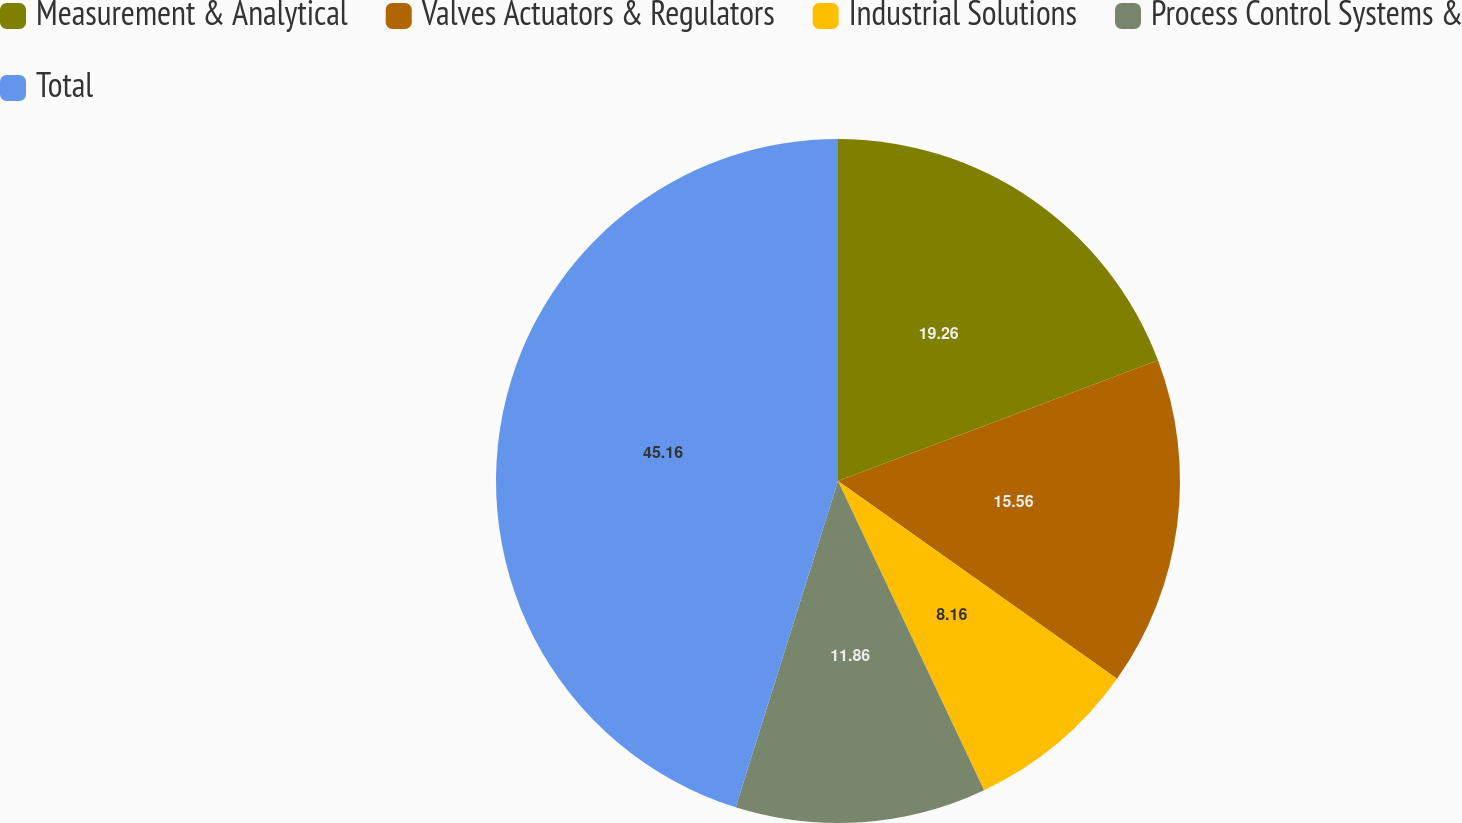<chart> <loc_0><loc_0><loc_500><loc_500><pie_chart><fcel>Measurement & Analytical<fcel>Valves Actuators & Regulators<fcel>Industrial Solutions<fcel>Process Control Systems &<fcel>Total<nl><fcel>19.26%<fcel>15.56%<fcel>8.16%<fcel>11.86%<fcel>45.17%<nl></chart> 